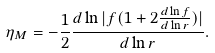Convert formula to latex. <formula><loc_0><loc_0><loc_500><loc_500>\eta _ { M } = - \frac { 1 } { 2 } \frac { d \ln | f ( 1 + 2 \frac { d \ln f } { d \ln r } ) | } { d \ln r } .</formula> 